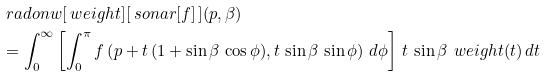Convert formula to latex. <formula><loc_0><loc_0><loc_500><loc_500>& \ r a d o n w [ \ w e i g h t ] [ \ s o n a r [ f ] \, ] ( p , \beta ) \\ & = \int _ { 0 } ^ { \infty } \left [ \int _ { 0 } ^ { \pi } f \left ( p + t \, ( 1 + \sin \beta \, \cos \phi ) , t \, \sin \beta \, \sin \phi \right ) \, d \phi \right ] \, t \, \sin \beta \, \ w e i g h t ( t ) \, d t</formula> 